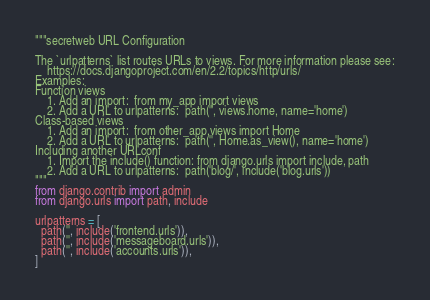<code> <loc_0><loc_0><loc_500><loc_500><_Python_>"""secretweb URL Configuration

The `urlpatterns` list routes URLs to views. For more information please see:
    https://docs.djangoproject.com/en/2.2/topics/http/urls/
Examples:
Function views
    1. Add an import:  from my_app import views
    2. Add a URL to urlpatterns:  path('', views.home, name='home')
Class-based views
    1. Add an import:  from other_app.views import Home
    2. Add a URL to urlpatterns:  path('', Home.as_view(), name='home')
Including another URLconf
    1. Import the include() function: from django.urls import include, path
    2. Add a URL to urlpatterns:  path('blog/', include('blog.urls'))
"""
from django.contrib import admin
from django.urls import path, include

urlpatterns = [
  path('', include('frontend.urls')), 
  path('', include('messageboard.urls')),
  path('', include('accounts.urls')),
]
</code> 